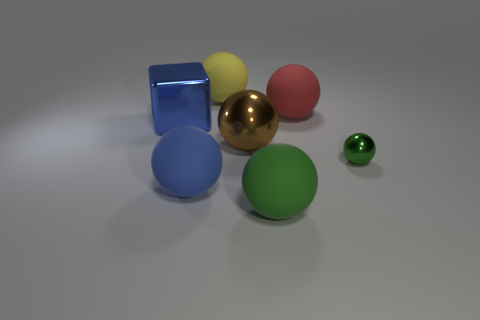Subtract all large brown metallic spheres. How many spheres are left? 5 Subtract all yellow spheres. How many spheres are left? 5 Subtract all spheres. How many objects are left? 1 Subtract 1 cubes. How many cubes are left? 0 Add 2 large blue balls. How many objects exist? 9 Subtract 0 cyan cubes. How many objects are left? 7 Subtract all cyan balls. Subtract all cyan blocks. How many balls are left? 6 Subtract all purple cylinders. How many cyan balls are left? 0 Subtract all large gray things. Subtract all metal things. How many objects are left? 4 Add 1 large balls. How many large balls are left? 6 